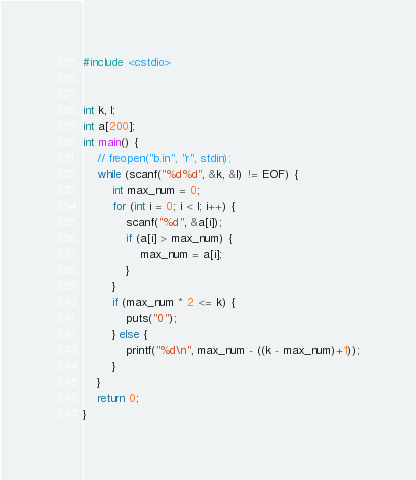<code> <loc_0><loc_0><loc_500><loc_500><_C++_>#include <cstdio>


int k, l;
int a[200];
int main() {
	// freopen("b.in", "r", stdin);
	while (scanf("%d%d", &k, &l) != EOF) {
		int max_num = 0;
		for (int i = 0; i < l; i++) {
			scanf("%d", &a[i]);
			if (a[i] > max_num) {
				max_num = a[i];
			}
		}
		if (max_num * 2 <= k) {
			puts("0");
		} else {
			printf("%d\n", max_num - ((k - max_num)+1));
		}
	}
	return 0;
}</code> 